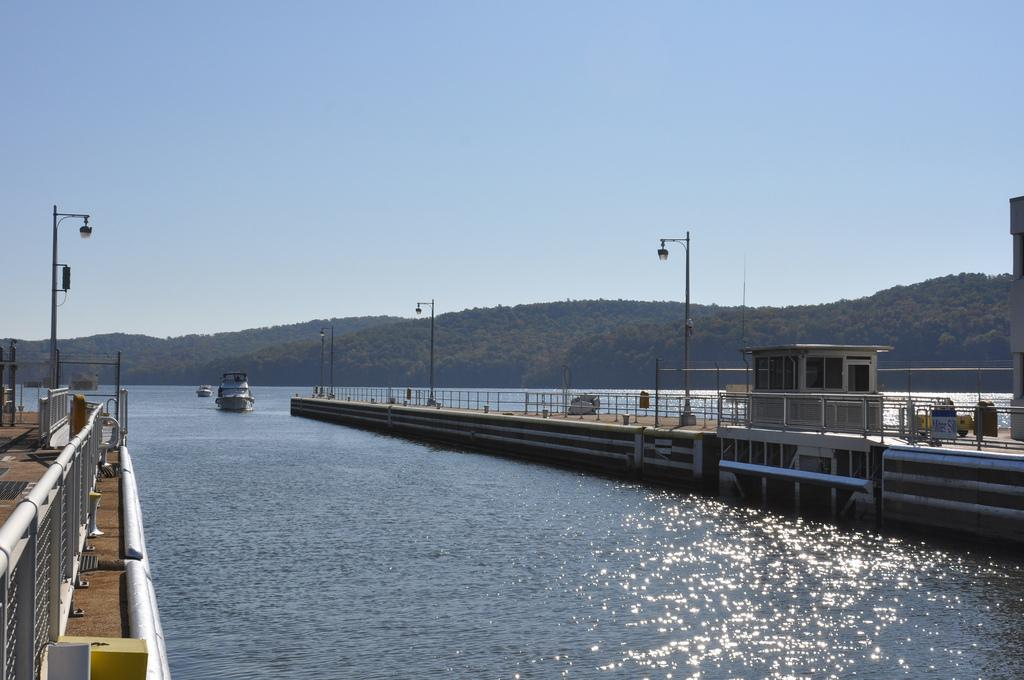What structures can be seen in the image? There are bridges in the image. What is present in the water in the image? There are two boats in the water. What are the lights attached to in the image? The lights are attached to poles in the image. What type of natural feature can be seen in the image? There are mountains visible in the image. What part of the environment is visible in the image? The sky is visible in the image. What type of cracker is being fed to the wren in the image? There is no wren or cracker present in the image. What hobbies are the people in the image participating in? The image does not show any people, so their hobbies cannot be determined. 